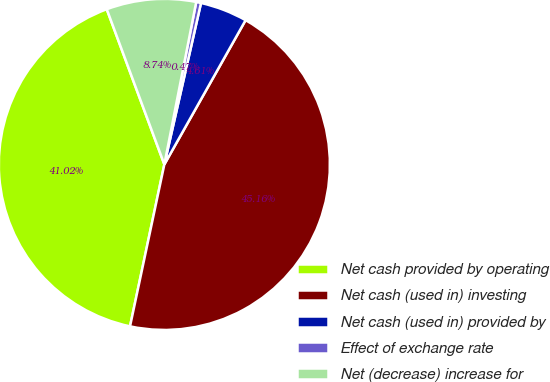Convert chart. <chart><loc_0><loc_0><loc_500><loc_500><pie_chart><fcel>Net cash provided by operating<fcel>Net cash (used in) investing<fcel>Net cash (used in) provided by<fcel>Effect of exchange rate<fcel>Net (decrease) increase for<nl><fcel>41.02%<fcel>45.16%<fcel>4.61%<fcel>0.47%<fcel>8.74%<nl></chart> 